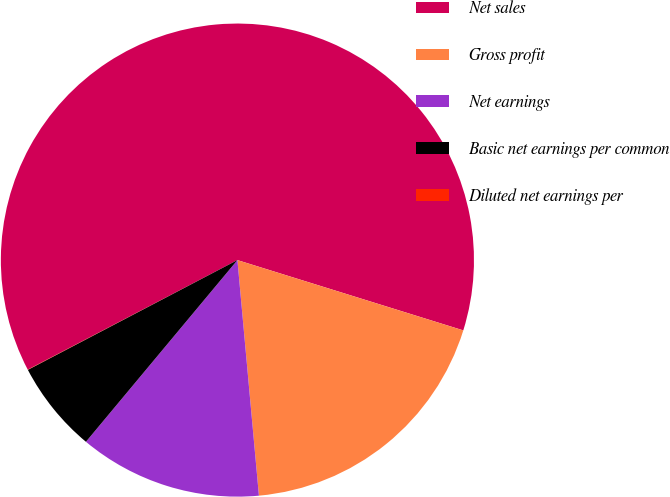Convert chart. <chart><loc_0><loc_0><loc_500><loc_500><pie_chart><fcel>Net sales<fcel>Gross profit<fcel>Net earnings<fcel>Basic net earnings per common<fcel>Diluted net earnings per<nl><fcel>62.46%<fcel>18.75%<fcel>12.51%<fcel>6.26%<fcel>0.02%<nl></chart> 